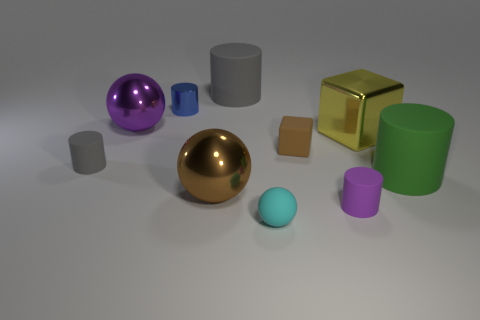Subtract all small blue cylinders. How many cylinders are left? 4 Subtract all green cylinders. How many cylinders are left? 4 Subtract all yellow cylinders. Subtract all green balls. How many cylinders are left? 5 Subtract all spheres. How many objects are left? 7 Add 8 big yellow objects. How many big yellow objects are left? 9 Add 1 green matte cylinders. How many green matte cylinders exist? 2 Subtract 1 purple cylinders. How many objects are left? 9 Subtract all tiny red shiny spheres. Subtract all cyan matte spheres. How many objects are left? 9 